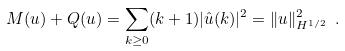Convert formula to latex. <formula><loc_0><loc_0><loc_500><loc_500>M ( u ) + Q ( u ) = \sum _ { k \geq 0 } ( k + 1 ) | \hat { u } ( k ) | ^ { 2 } = \| u \| _ { H ^ { 1 / 2 } } ^ { 2 } \ .</formula> 